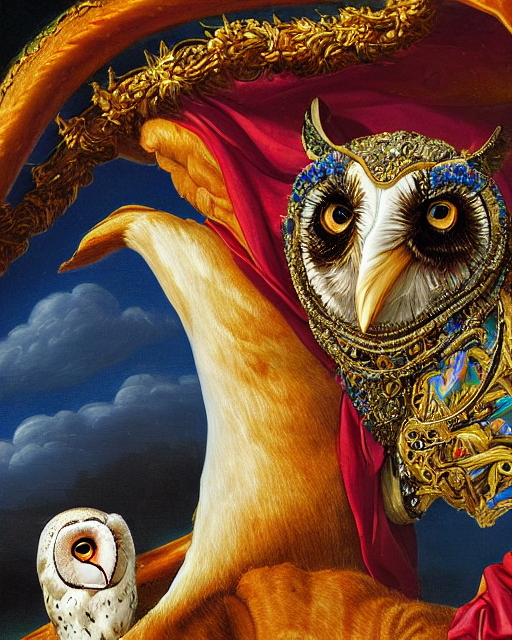Is there any apparent noise in the image? Upon close examination, the image appears to be of high quality without any noticeable noise disrupting the clarity of its elements. The crisp detail in the artwork allows individual textures and colors to stand out distinctly. 